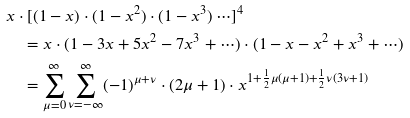Convert formula to latex. <formula><loc_0><loc_0><loc_500><loc_500>& x \cdot [ ( 1 - x ) \cdot ( 1 - x ^ { 2 } ) \cdot ( 1 - x ^ { 3 } ) \cdots ] ^ { 4 } \\ & \quad = x \cdot ( 1 - 3 x + 5 x ^ { 2 } - 7 x ^ { 3 } + \cdots ) \cdot ( 1 - x - x ^ { 2 } + x ^ { 3 } + \cdots ) \\ & \quad = \sum _ { \mu = 0 } ^ { \infty } \sum _ { \nu = - \infty } ^ { \infty } ( - 1 ) ^ { \mu + \nu } \cdot ( 2 \mu + 1 ) \cdot x ^ { 1 + \frac { 1 } { 2 } \mu ( \mu + 1 ) + \frac { 1 } { 2 } \nu ( 3 \nu + 1 ) }</formula> 